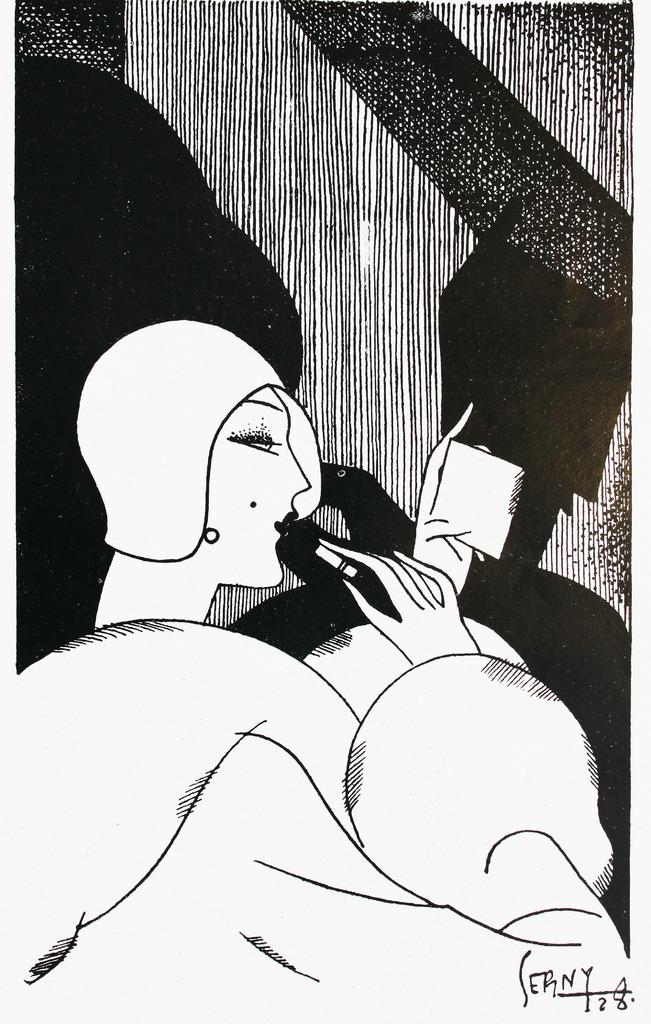What is depicted in the painting? There is a person in the painting. What is the person doing in the painting? The person is holding an object with one hand and another object with the other hand. Can you describe the background of the painting? There are designs in the background of the painting. What type of crime is being committed in the painting? There is no crime depicted in the painting; it shows a person holding two objects. What action is the person taking in the painting? The person is holding two objects, but there is no specific action being performed. 